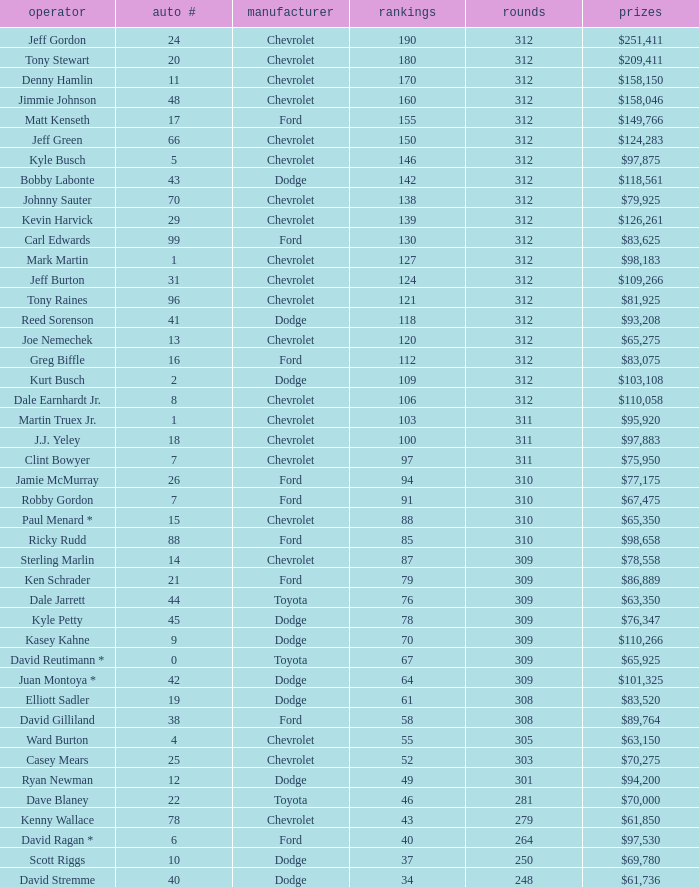What is the sum of laps that has a car number of larger than 1, is a ford, and has 155 points? 312.0. 